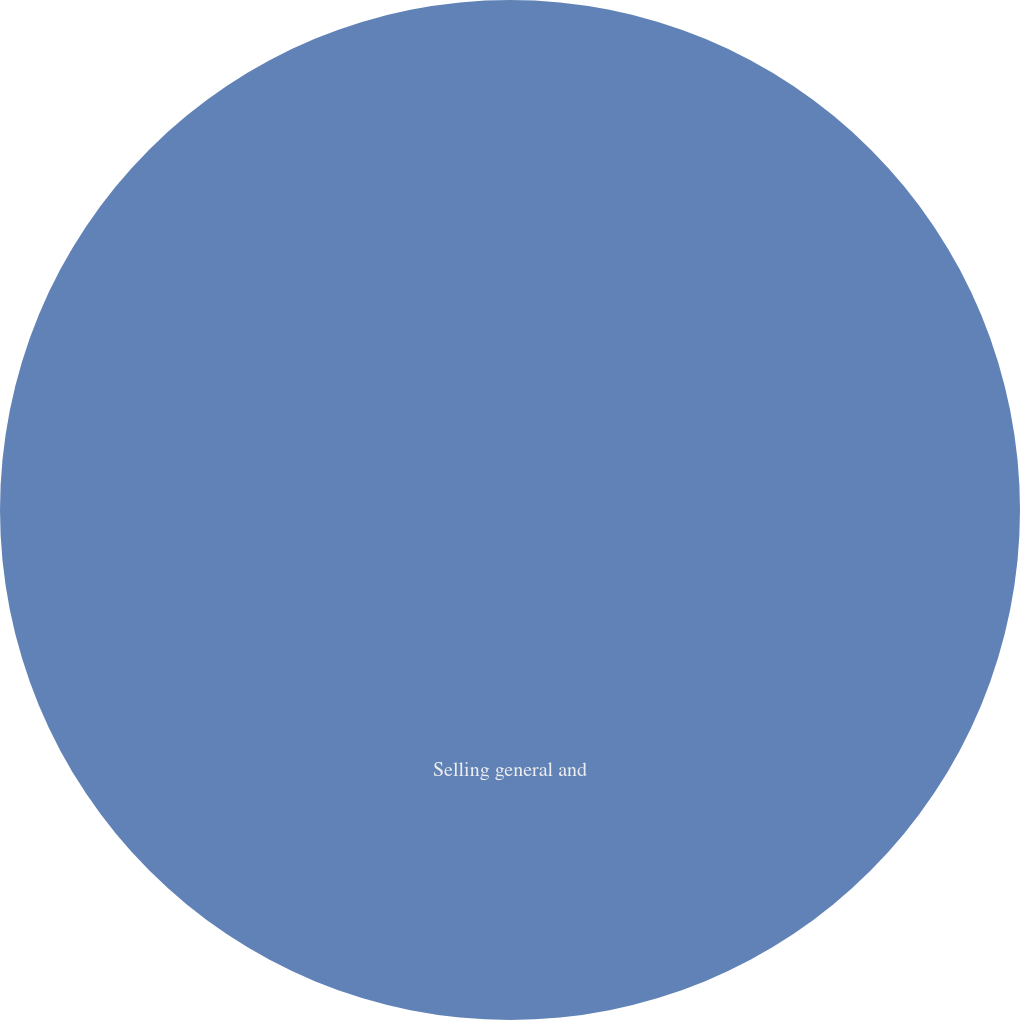<chart> <loc_0><loc_0><loc_500><loc_500><pie_chart><fcel>Selling general and<nl><fcel>100.0%<nl></chart> 